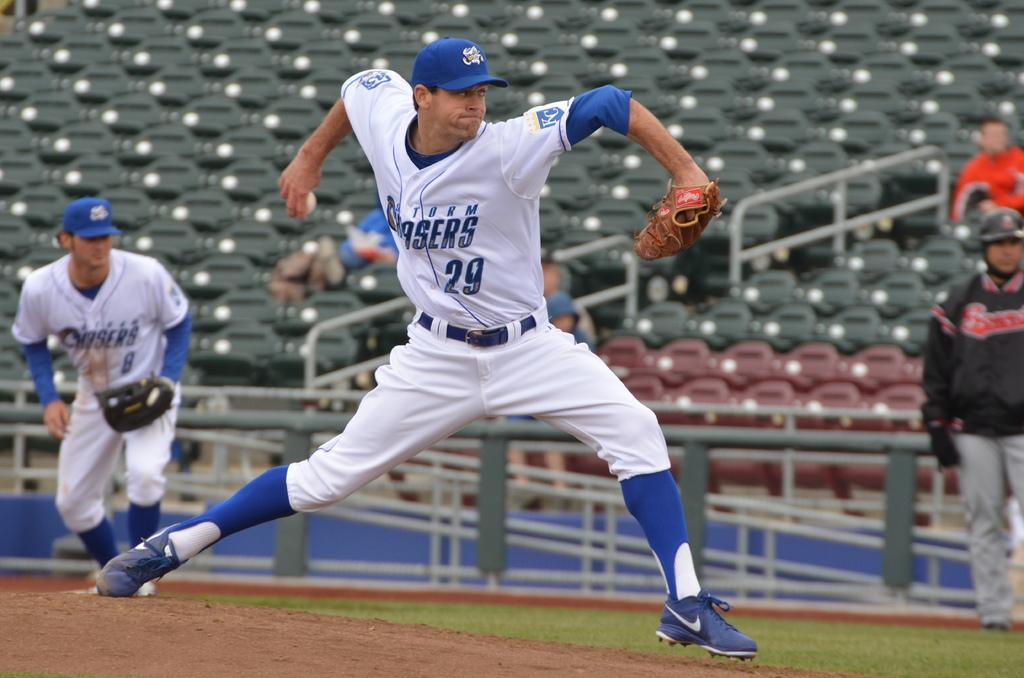Provide a one-sentence caption for the provided image. a man in white and blue playing sports wearing a shirt with 29 on it. 